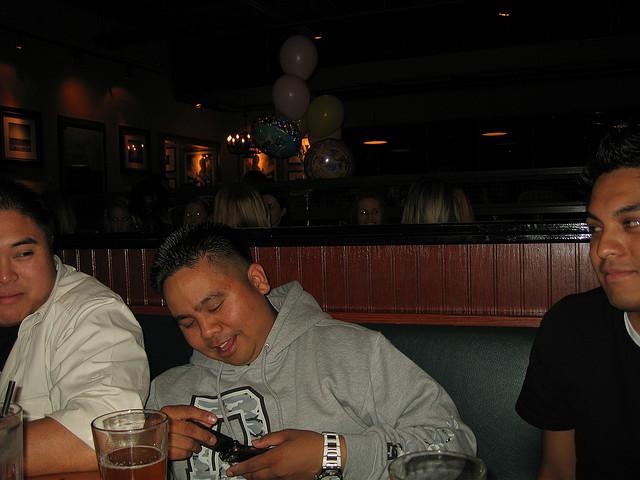What type of game is the man playing?
Be succinct. Phone. Is the man awake?
Be succinct. Yes. Is there a cab in this picture?
Concise answer only. No. How many lights are visible on the wall?
Quick response, please. 2. What is the design on the shirt behind the man?
Be succinct. None. How many men are in this picture?
Be succinct. 3. How many faces is written on the foto?
Short answer required. 3. Are the men American?
Write a very short answer. No. What drink is he making?
Give a very brief answer. Beer. How many people?
Answer briefly. 3. What is in the man's hands?
Quick response, please. Cell phone. What does it look like the men are doing?
Short answer required. Drinking. Is this man a famous player?
Quick response, please. No. How many people are wearing a tie?
Short answer required. 0. What color is the guys' sweater?
Be succinct. Gray. What kind of room are the people in?
Quick response, please. Bar. What is the date of this photo?
Short answer required. No date. Is this man wearing a necktie?
Quick response, please. No. Is this a conference?
Concise answer only. No. Is that a clamshell phone?
Answer briefly. Yes. Is the man drinking wine?
Keep it brief. No. Where are the people in the photograph?
Keep it brief. Bar. Where are the plates?
Concise answer only. On table. What kind of glass is the man drinking from?
Concise answer only. Beer. 